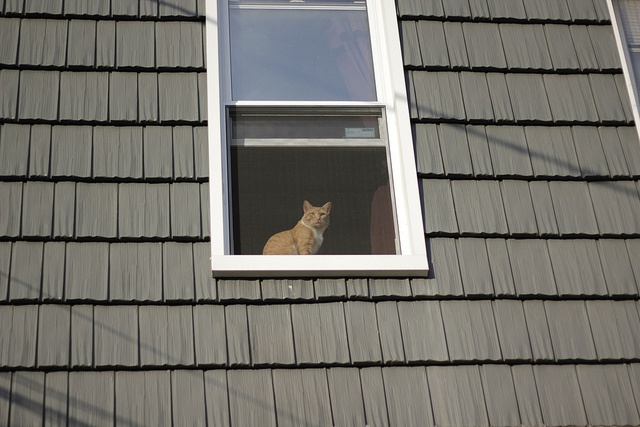Describe the objects in this image and their specific colors. I can see a cat in gray, black, and tan tones in this image. 